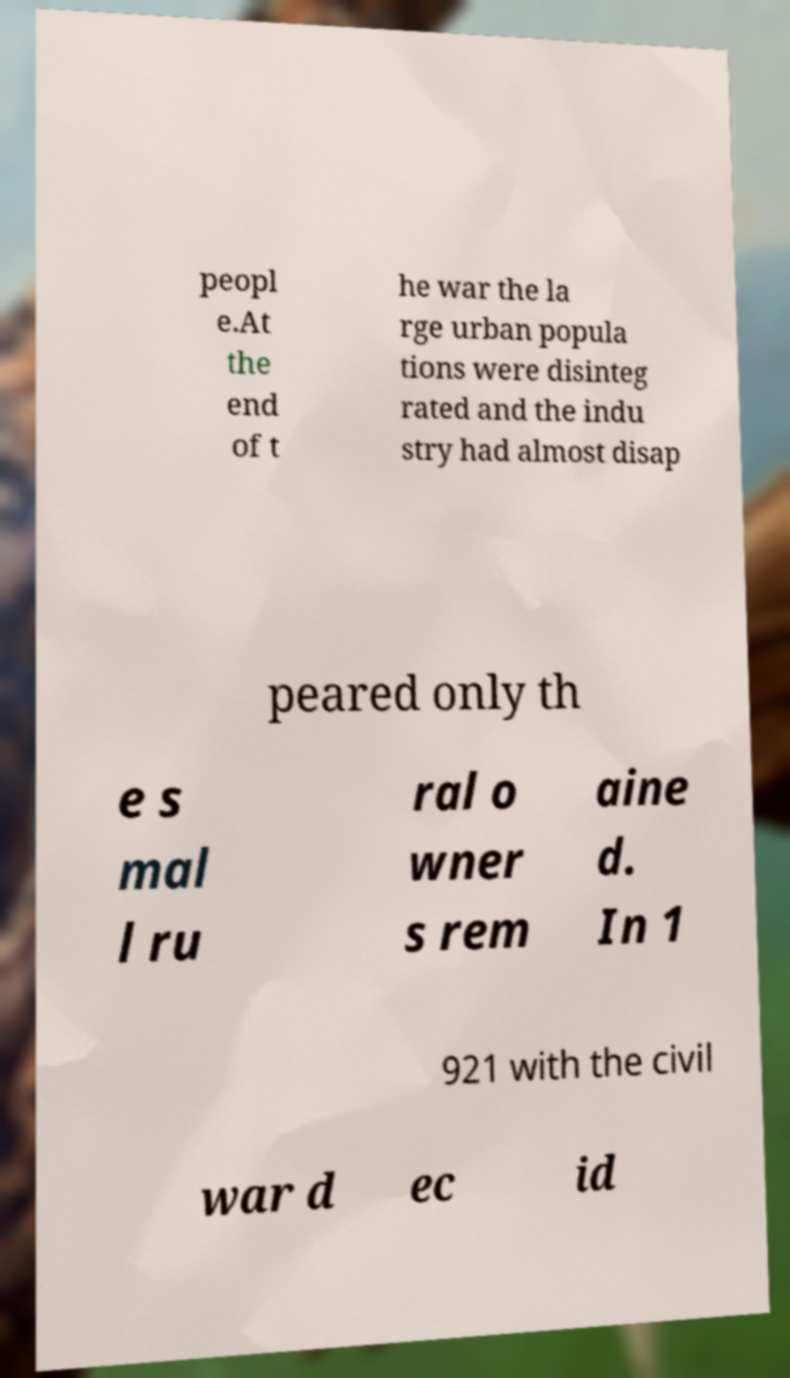What messages or text are displayed in this image? I need them in a readable, typed format. peopl e.At the end of t he war the la rge urban popula tions were disinteg rated and the indu stry had almost disap peared only th e s mal l ru ral o wner s rem aine d. In 1 921 with the civil war d ec id 